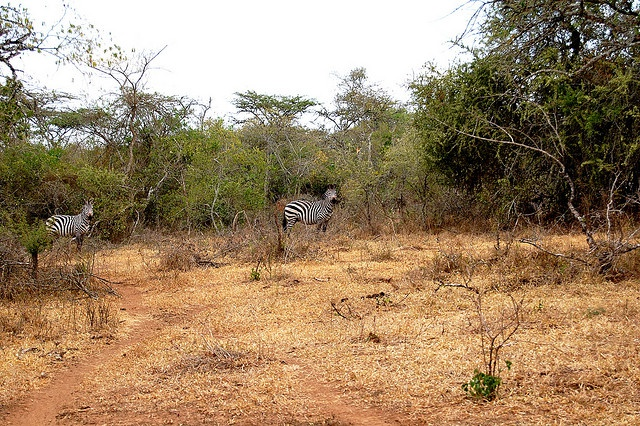Describe the objects in this image and their specific colors. I can see zebra in white, black, gray, lightgray, and darkgray tones and zebra in white, black, gray, darkgray, and lightgray tones in this image. 